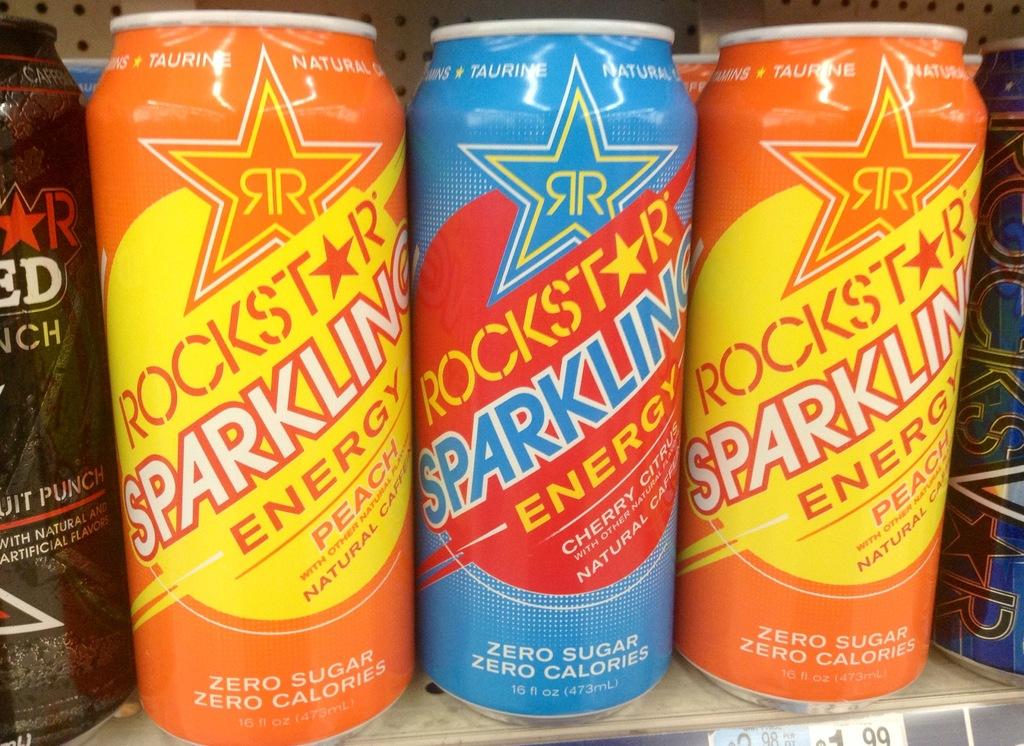What flavor is the orange rockstar drink?
Give a very brief answer. Peach. What flavor is the blue drink?
Provide a succinct answer. Cherry. 